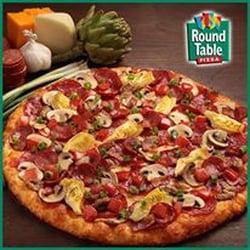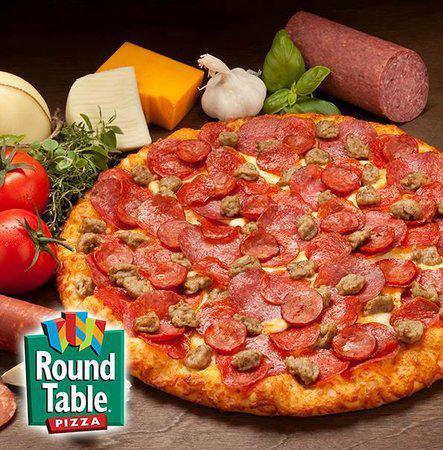The first image is the image on the left, the second image is the image on the right. Given the left and right images, does the statement "There's a whole head of garlic and at least one tomato next to the pizza in one of the pictures." hold true? Answer yes or no. Yes. The first image is the image on the left, the second image is the image on the right. Considering the images on both sides, is "There is a pizza with exactly one missing slice." valid? Answer yes or no. No. 